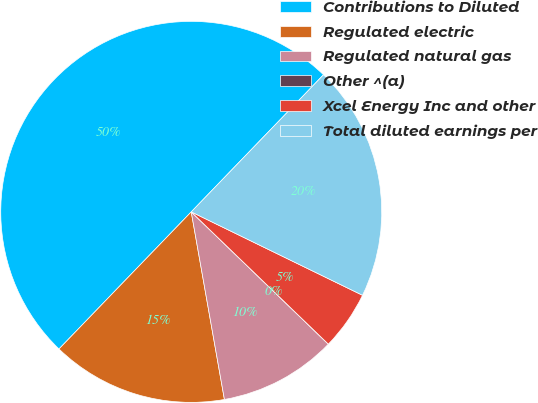Convert chart to OTSL. <chart><loc_0><loc_0><loc_500><loc_500><pie_chart><fcel>Contributions to Diluted<fcel>Regulated electric<fcel>Regulated natural gas<fcel>Other ^(a)<fcel>Xcel Energy Inc and other<fcel>Total diluted earnings per<nl><fcel>50.0%<fcel>15.0%<fcel>10.0%<fcel>0.0%<fcel>5.0%<fcel>20.0%<nl></chart> 